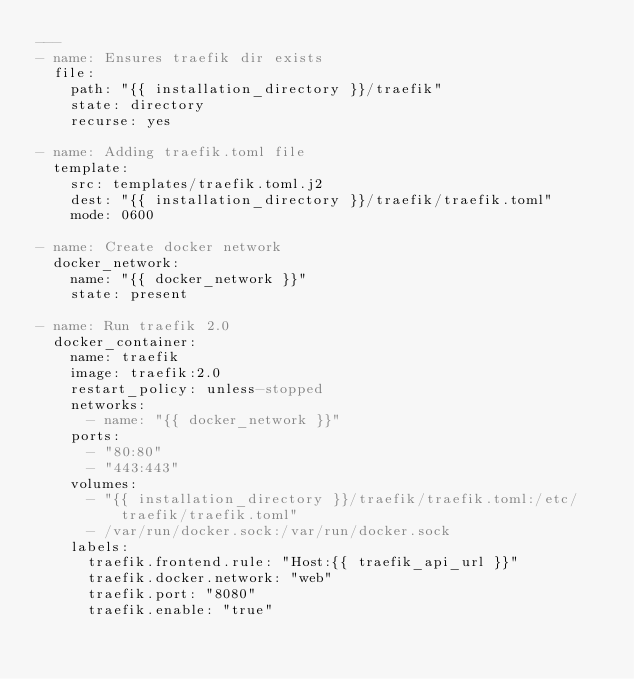<code> <loc_0><loc_0><loc_500><loc_500><_YAML_>---
- name: Ensures traefik dir exists
  file:
    path: "{{ installation_directory }}/traefik"
    state: directory
    recurse: yes

- name: Adding traefik.toml file
  template:
    src: templates/traefik.toml.j2
    dest: "{{ installation_directory }}/traefik/traefik.toml"
    mode: 0600

- name: Create docker network
  docker_network:
    name: "{{ docker_network }}"
    state: present

- name: Run traefik 2.0
  docker_container:
    name: traefik
    image: traefik:2.0
    restart_policy: unless-stopped
    networks:
      - name: "{{ docker_network }}"
    ports:
      - "80:80"
      - "443:443"
    volumes:
      - "{{ installation_directory }}/traefik/traefik.toml:/etc/traefik/traefik.toml"
      - /var/run/docker.sock:/var/run/docker.sock
    labels:
      traefik.frontend.rule: "Host:{{ traefik_api_url }}"
      traefik.docker.network: "web"
      traefik.port: "8080"
      traefik.enable: "true"
</code> 